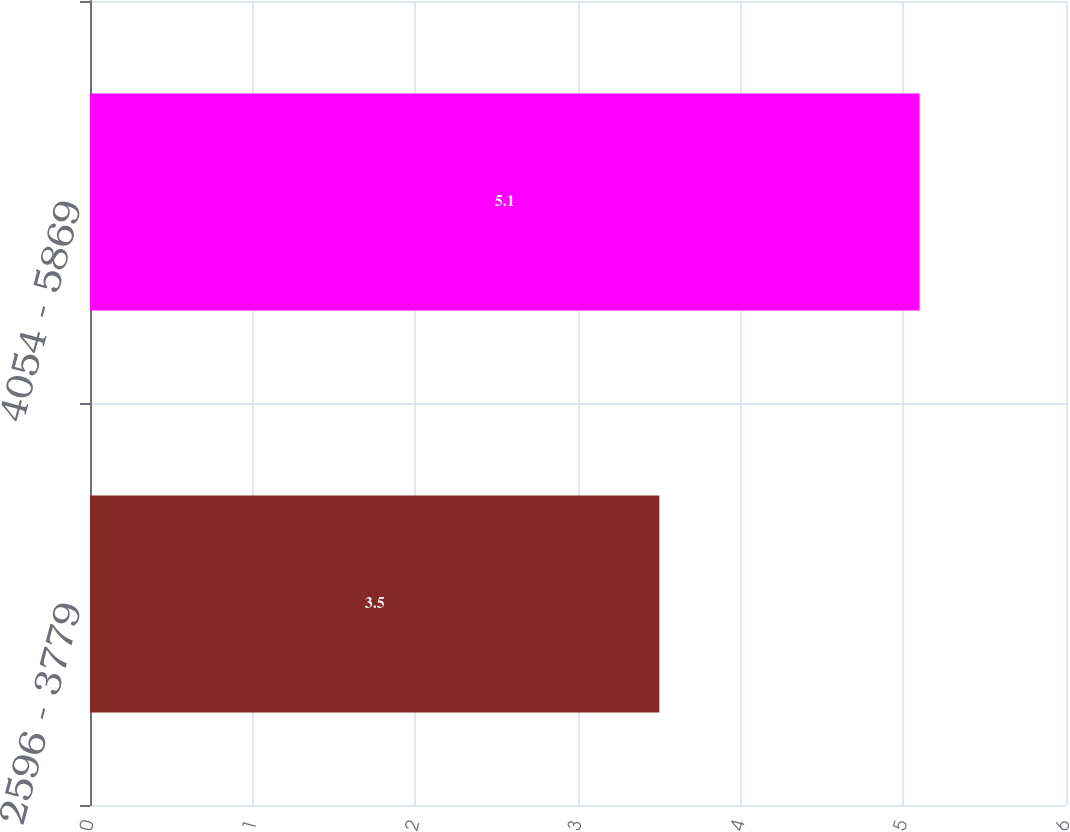<chart> <loc_0><loc_0><loc_500><loc_500><bar_chart><fcel>2596 - 3779<fcel>4054 - 5869<nl><fcel>3.5<fcel>5.1<nl></chart> 